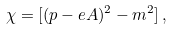Convert formula to latex. <formula><loc_0><loc_0><loc_500><loc_500>\chi = [ ( p - e A ) ^ { 2 } - m ^ { 2 } ] \, ,</formula> 